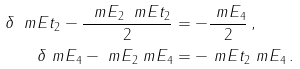<formula> <loc_0><loc_0><loc_500><loc_500>\delta \ m E t _ { 2 } - \frac { \ m E _ { 2 } \ m E t _ { 2 } } { 2 } & = - \frac { \ m E _ { 4 } } { 2 } \, , \\ \delta \ m E _ { 4 } - \ m E _ { 2 } \ m E _ { 4 } & = - \ m E t _ { 2 } \ m E _ { 4 } \, .</formula> 